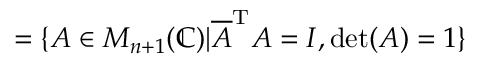Convert formula to latex. <formula><loc_0><loc_0><loc_500><loc_500>= \{ A \in M _ { n + 1 } ( \mathbb { C } ) | { \overline { A } } ^ { T } A = I , \det ( A ) = 1 \}</formula> 